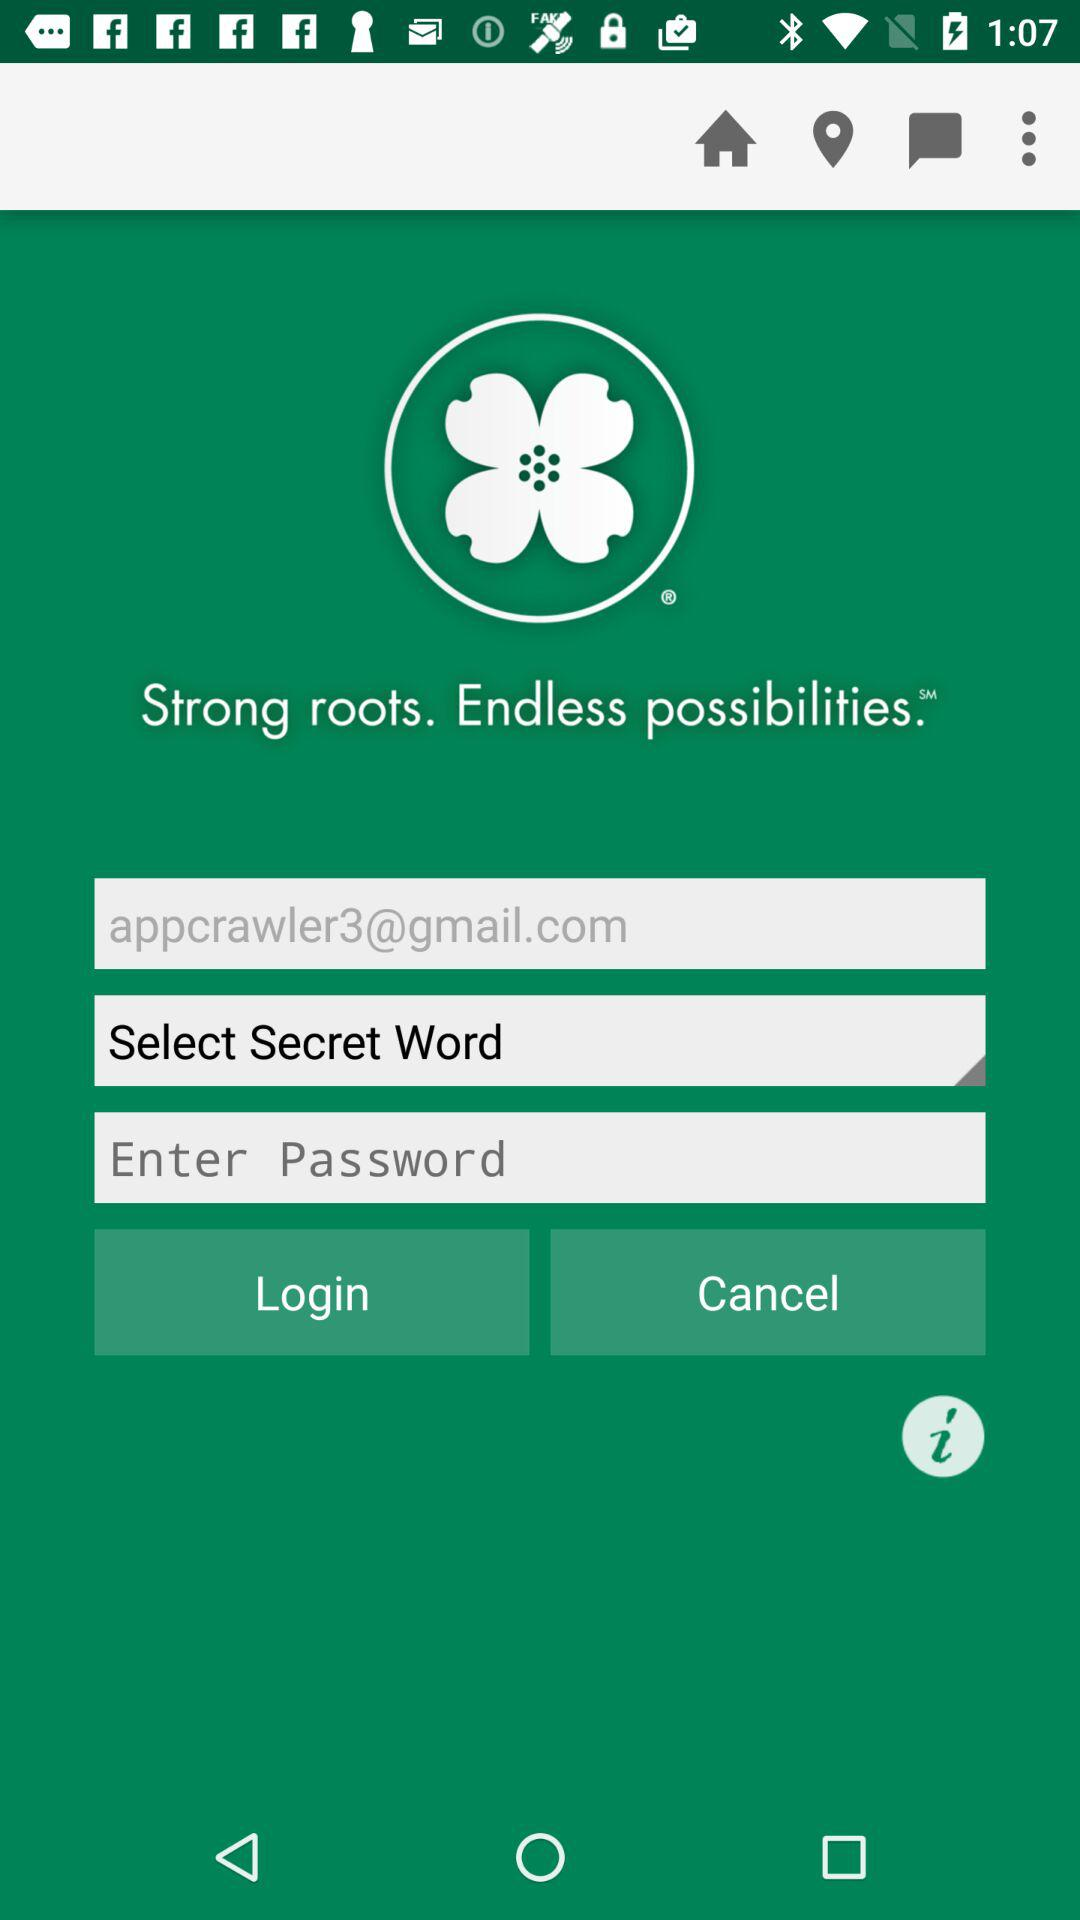What is the email address? The email address is "appcrawler3@gmail.com". 